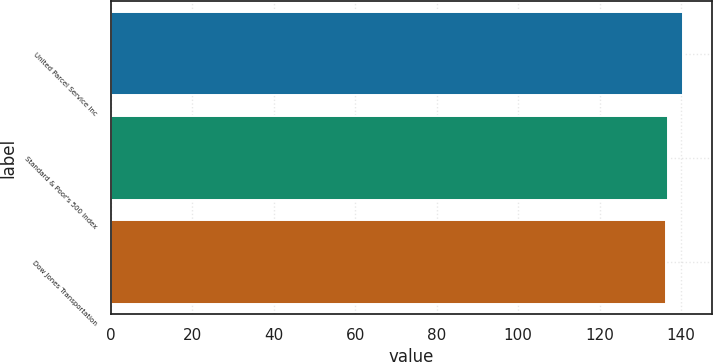Convert chart. <chart><loc_0><loc_0><loc_500><loc_500><bar_chart><fcel>United Parcel Service Inc<fcel>Standard & Poor's 500 Index<fcel>Dow Jones Transportation<nl><fcel>140.54<fcel>136.67<fcel>136.24<nl></chart> 